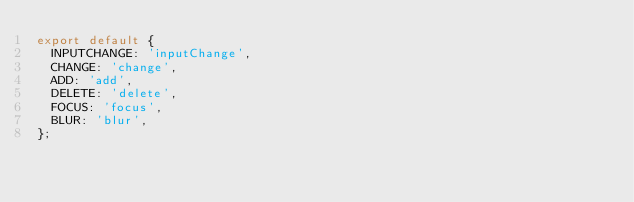<code> <loc_0><loc_0><loc_500><loc_500><_JavaScript_>export default {
  INPUTCHANGE: 'inputChange',
  CHANGE: 'change',
  ADD: 'add',
  DELETE: 'delete',
  FOCUS: 'focus',
  BLUR: 'blur',
};
</code> 